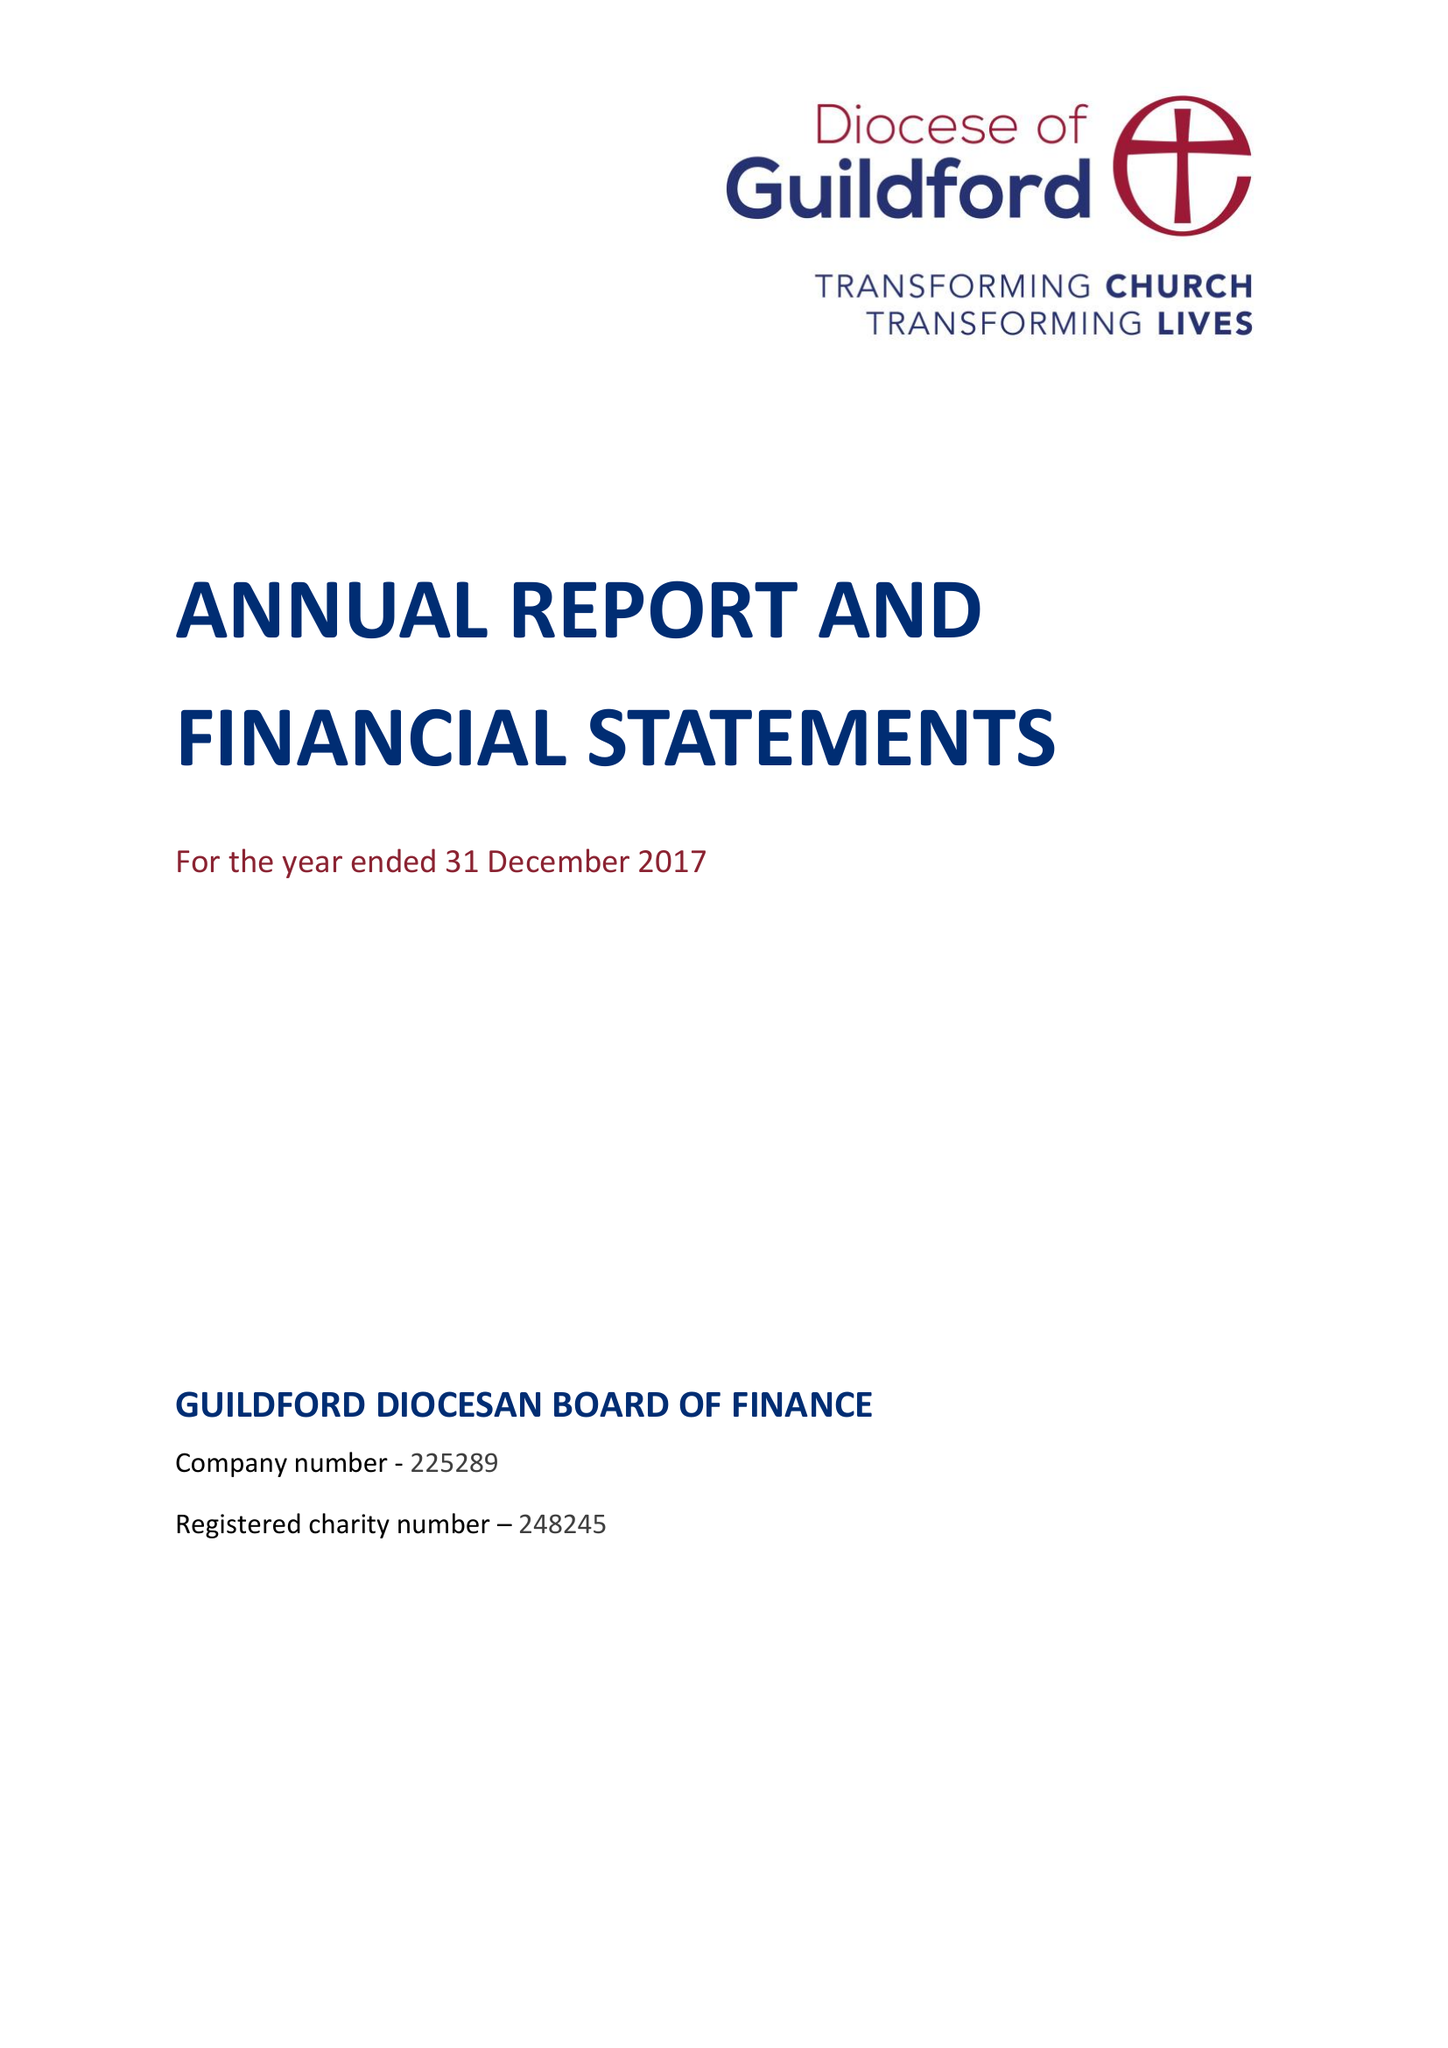What is the value for the spending_annually_in_british_pounds?
Answer the question using a single word or phrase. 13034000.00 